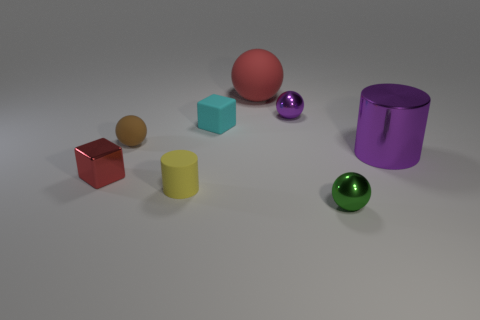What shapes are the objects besides the spheres? Apart from the spheres, there are two cubes, one red and one cyan, and two cylinders, one yellow and one purple. Do any of the objects share the same material property? Based on the image, it's not entirely clear which objects share the same material properties as they might differ in texture or finish. However, the cylinders seem to have a similar matte finish. 